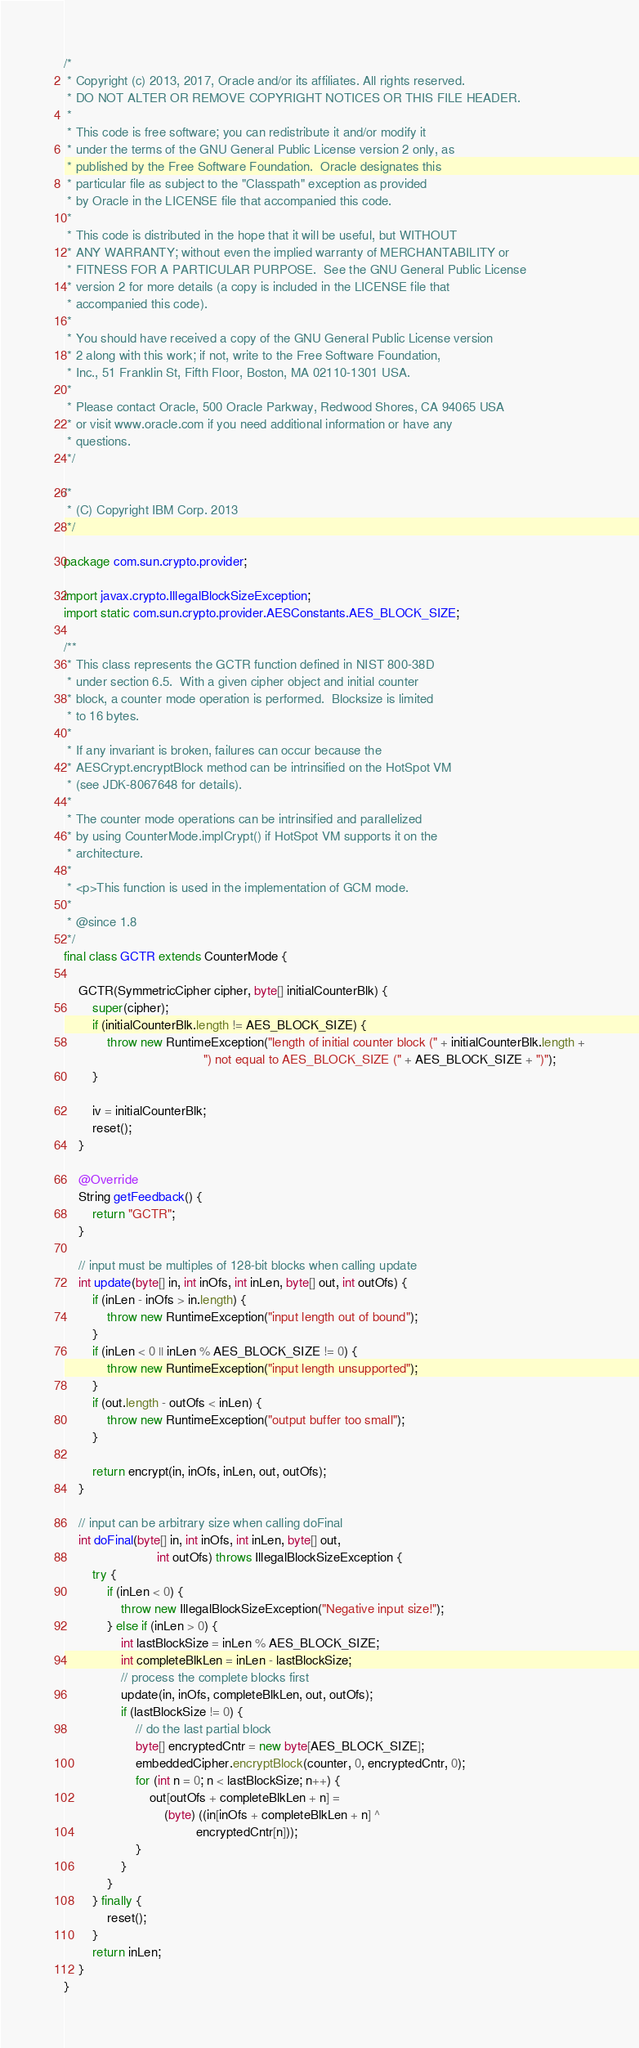Convert code to text. <code><loc_0><loc_0><loc_500><loc_500><_Java_>/*
 * Copyright (c) 2013, 2017, Oracle and/or its affiliates. All rights reserved.
 * DO NOT ALTER OR REMOVE COPYRIGHT NOTICES OR THIS FILE HEADER.
 *
 * This code is free software; you can redistribute it and/or modify it
 * under the terms of the GNU General Public License version 2 only, as
 * published by the Free Software Foundation.  Oracle designates this
 * particular file as subject to the "Classpath" exception as provided
 * by Oracle in the LICENSE file that accompanied this code.
 *
 * This code is distributed in the hope that it will be useful, but WITHOUT
 * ANY WARRANTY; without even the implied warranty of MERCHANTABILITY or
 * FITNESS FOR A PARTICULAR PURPOSE.  See the GNU General Public License
 * version 2 for more details (a copy is included in the LICENSE file that
 * accompanied this code).
 *
 * You should have received a copy of the GNU General Public License version
 * 2 along with this work; if not, write to the Free Software Foundation,
 * Inc., 51 Franklin St, Fifth Floor, Boston, MA 02110-1301 USA.
 *
 * Please contact Oracle, 500 Oracle Parkway, Redwood Shores, CA 94065 USA
 * or visit www.oracle.com if you need additional information or have any
 * questions.
 */

/*
 * (C) Copyright IBM Corp. 2013
 */

package com.sun.crypto.provider;

import javax.crypto.IllegalBlockSizeException;
import static com.sun.crypto.provider.AESConstants.AES_BLOCK_SIZE;

/**
 * This class represents the GCTR function defined in NIST 800-38D
 * under section 6.5.  With a given cipher object and initial counter
 * block, a counter mode operation is performed.  Blocksize is limited
 * to 16 bytes.
 *
 * If any invariant is broken, failures can occur because the
 * AESCrypt.encryptBlock method can be intrinsified on the HotSpot VM
 * (see JDK-8067648 for details).
 *
 * The counter mode operations can be intrinsified and parallelized
 * by using CounterMode.implCrypt() if HotSpot VM supports it on the
 * architecture.
 *
 * <p>This function is used in the implementation of GCM mode.
 *
 * @since 1.8
 */
final class GCTR extends CounterMode {

    GCTR(SymmetricCipher cipher, byte[] initialCounterBlk) {
        super(cipher);
        if (initialCounterBlk.length != AES_BLOCK_SIZE) {
            throw new RuntimeException("length of initial counter block (" + initialCounterBlk.length +
                                       ") not equal to AES_BLOCK_SIZE (" + AES_BLOCK_SIZE + ")");
        }

        iv = initialCounterBlk;
        reset();
    }

    @Override
    String getFeedback() {
        return "GCTR";
    }

    // input must be multiples of 128-bit blocks when calling update
    int update(byte[] in, int inOfs, int inLen, byte[] out, int outOfs) {
        if (inLen - inOfs > in.length) {
            throw new RuntimeException("input length out of bound");
        }
        if (inLen < 0 || inLen % AES_BLOCK_SIZE != 0) {
            throw new RuntimeException("input length unsupported");
        }
        if (out.length - outOfs < inLen) {
            throw new RuntimeException("output buffer too small");
        }

        return encrypt(in, inOfs, inLen, out, outOfs);
    }

    // input can be arbitrary size when calling doFinal
    int doFinal(byte[] in, int inOfs, int inLen, byte[] out,
                          int outOfs) throws IllegalBlockSizeException {
        try {
            if (inLen < 0) {
                throw new IllegalBlockSizeException("Negative input size!");
            } else if (inLen > 0) {
                int lastBlockSize = inLen % AES_BLOCK_SIZE;
                int completeBlkLen = inLen - lastBlockSize;
                // process the complete blocks first
                update(in, inOfs, completeBlkLen, out, outOfs);
                if (lastBlockSize != 0) {
                    // do the last partial block
                    byte[] encryptedCntr = new byte[AES_BLOCK_SIZE];
                    embeddedCipher.encryptBlock(counter, 0, encryptedCntr, 0);
                    for (int n = 0; n < lastBlockSize; n++) {
                        out[outOfs + completeBlkLen + n] =
                            (byte) ((in[inOfs + completeBlkLen + n] ^
                                     encryptedCntr[n]));
                    }
                }
            }
        } finally {
            reset();
        }
        return inLen;
    }
}
</code> 